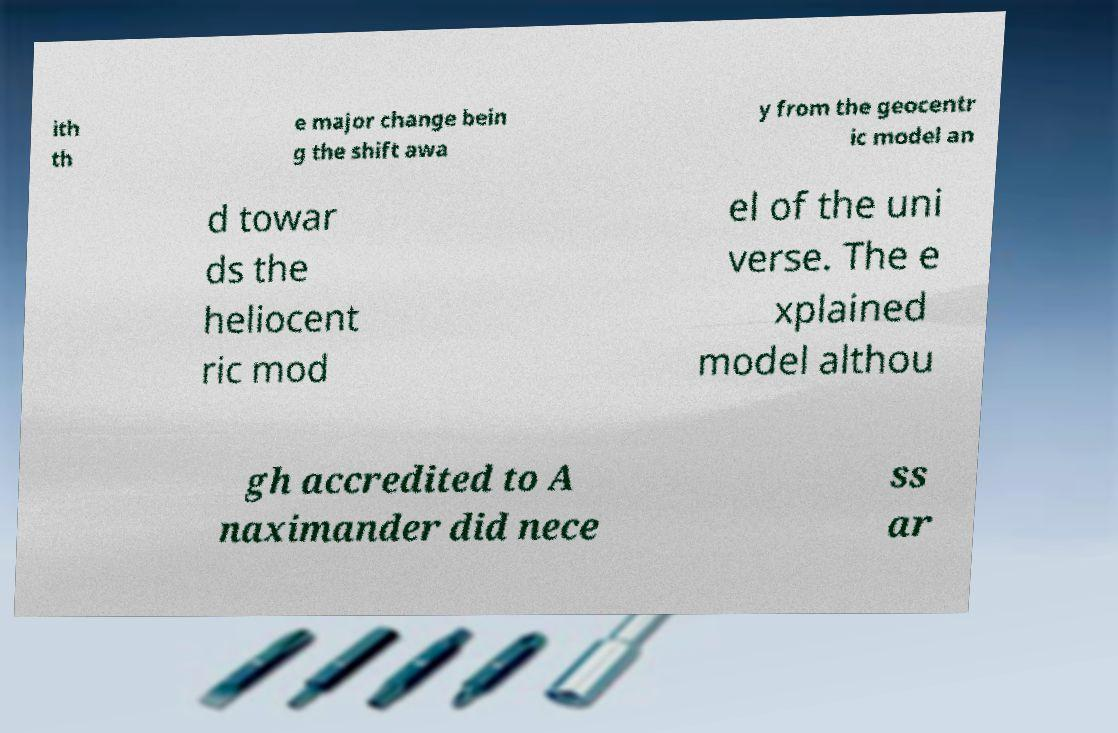Could you assist in decoding the text presented in this image and type it out clearly? ith th e major change bein g the shift awa y from the geocentr ic model an d towar ds the heliocent ric mod el of the uni verse. The e xplained model althou gh accredited to A naximander did nece ss ar 